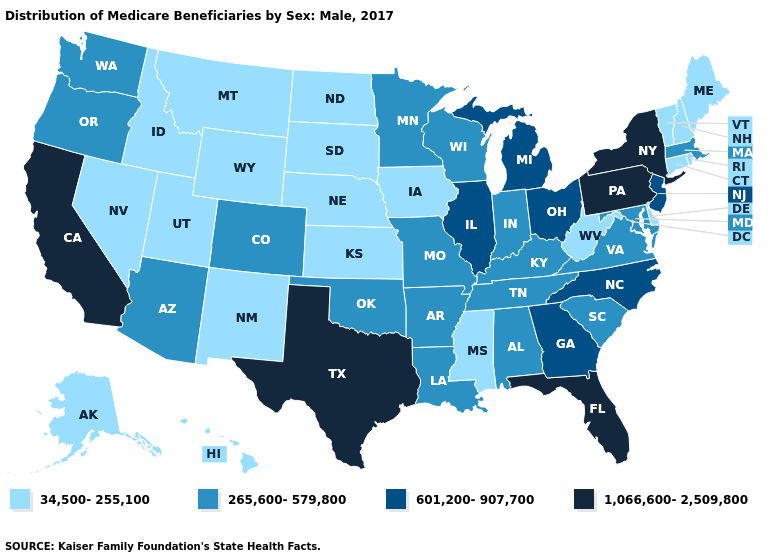Among the states that border Florida , which have the lowest value?
Concise answer only. Alabama. What is the lowest value in the USA?
Keep it brief. 34,500-255,100. Does California have the highest value in the West?
Be succinct. Yes. Does Washington have a higher value than Alaska?
Be succinct. Yes. What is the lowest value in states that border Maryland?
Keep it brief. 34,500-255,100. What is the highest value in the USA?
Short answer required. 1,066,600-2,509,800. What is the value of Tennessee?
Short answer required. 265,600-579,800. Name the states that have a value in the range 1,066,600-2,509,800?
Give a very brief answer. California, Florida, New York, Pennsylvania, Texas. Name the states that have a value in the range 34,500-255,100?
Keep it brief. Alaska, Connecticut, Delaware, Hawaii, Idaho, Iowa, Kansas, Maine, Mississippi, Montana, Nebraska, Nevada, New Hampshire, New Mexico, North Dakota, Rhode Island, South Dakota, Utah, Vermont, West Virginia, Wyoming. Name the states that have a value in the range 265,600-579,800?
Quick response, please. Alabama, Arizona, Arkansas, Colorado, Indiana, Kentucky, Louisiana, Maryland, Massachusetts, Minnesota, Missouri, Oklahoma, Oregon, South Carolina, Tennessee, Virginia, Washington, Wisconsin. What is the value of Nevada?
Concise answer only. 34,500-255,100. What is the lowest value in the Northeast?
Short answer required. 34,500-255,100. Does Hawaii have a lower value than Utah?
Short answer required. No. What is the value of New Mexico?
Answer briefly. 34,500-255,100. What is the value of New Mexico?
Short answer required. 34,500-255,100. 